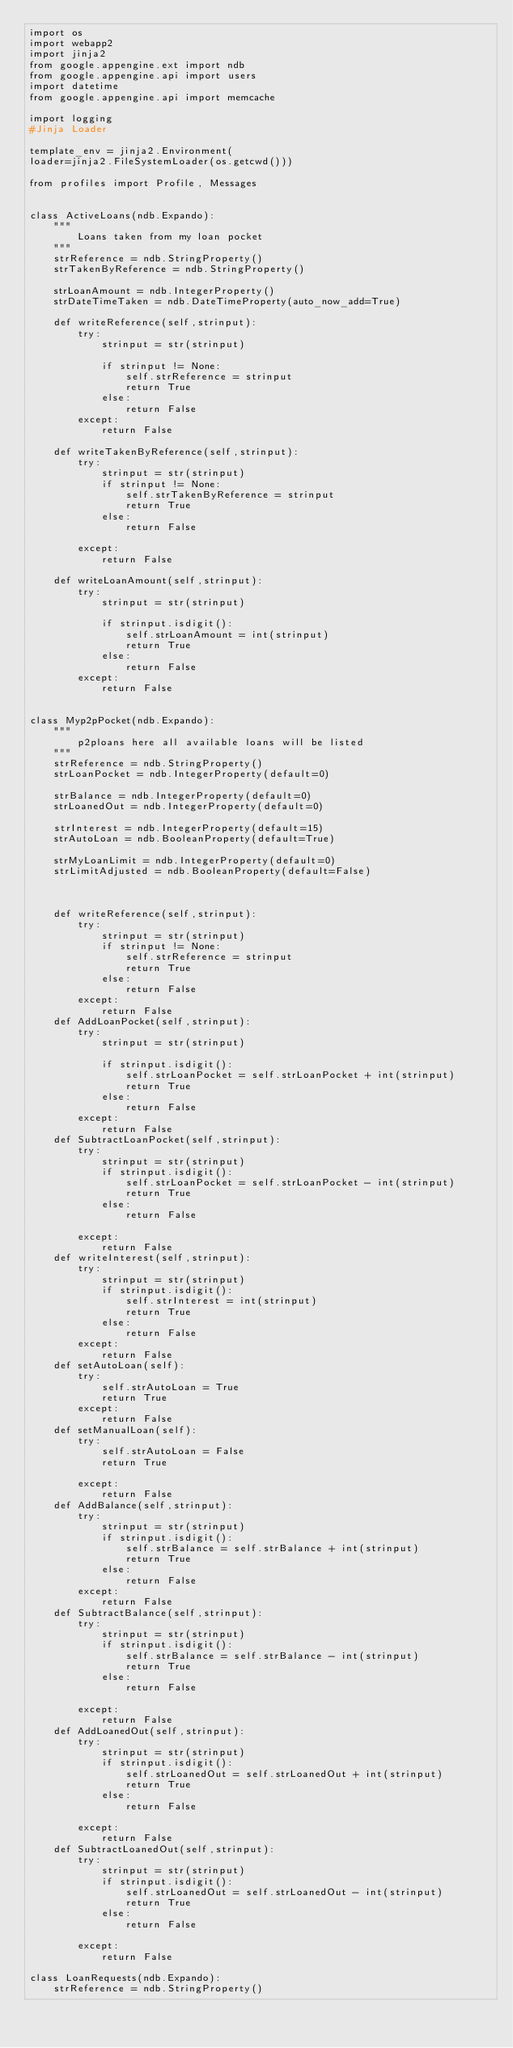Convert code to text. <code><loc_0><loc_0><loc_500><loc_500><_Python_>import os
import webapp2
import jinja2
from google.appengine.ext import ndb
from google.appengine.api import users
import datetime
from google.appengine.api import memcache

import logging
#Jinja Loader

template_env = jinja2.Environment(
loader=jinja2.FileSystemLoader(os.getcwd()))

from profiles import Profile, Messages


class ActiveLoans(ndb.Expando):
    """
        Loans taken from my loan pocket
    """
    strReference = ndb.StringProperty()
    strTakenByReference = ndb.StringProperty()

    strLoanAmount = ndb.IntegerProperty()
    strDateTimeTaken = ndb.DateTimeProperty(auto_now_add=True)

    def writeReference(self,strinput):
        try:
            strinput = str(strinput)

            if strinput != None:
                self.strReference = strinput
                return True
            else:
                return False
        except:
            return False

    def writeTakenByReference(self,strinput):
        try:
            strinput = str(strinput)
            if strinput != None:
                self.strTakenByReference = strinput
                return True
            else:
                return False

        except:
            return False

    def writeLoanAmount(self,strinput):
        try:
            strinput = str(strinput)

            if strinput.isdigit():
                self.strLoanAmount = int(strinput)
                return True
            else:
                return False
        except:
            return False


class Myp2pPocket(ndb.Expando):
    """
        p2ploans here all available loans will be listed
    """
    strReference = ndb.StringProperty()
    strLoanPocket = ndb.IntegerProperty(default=0)

    strBalance = ndb.IntegerProperty(default=0)
    strLoanedOut = ndb.IntegerProperty(default=0)

    strInterest = ndb.IntegerProperty(default=15)
    strAutoLoan = ndb.BooleanProperty(default=True)

    strMyLoanLimit = ndb.IntegerProperty(default=0)
    strLimitAdjusted = ndb.BooleanProperty(default=False)



    def writeReference(self,strinput):
        try:
            strinput = str(strinput)
            if strinput != None:
                self.strReference = strinput
                return True
            else:
                return False
        except:
            return False
    def AddLoanPocket(self,strinput):
        try:
            strinput = str(strinput)

            if strinput.isdigit():
                self.strLoanPocket = self.strLoanPocket + int(strinput)
                return True
            else:
                return False
        except:
            return False
    def SubtractLoanPocket(self,strinput):
        try:
            strinput = str(strinput)
            if strinput.isdigit():
                self.strLoanPocket = self.strLoanPocket - int(strinput)
                return True
            else:
                return False

        except:
            return False
    def writeInterest(self,strinput):
        try:
            strinput = str(strinput)
            if strinput.isdigit():
                self.strInterest = int(strinput)
                return True
            else:
                return False
        except:
            return False
    def setAutoLoan(self):
        try:
            self.strAutoLoan = True
            return True
        except:
            return False
    def setManualLoan(self):
        try:
            self.strAutoLoan = False
            return True

        except:
            return False
    def AddBalance(self,strinput):
        try:
            strinput = str(strinput)
            if strinput.isdigit():
                self.strBalance = self.strBalance + int(strinput)
                return True
            else:
                return False
        except:
            return False
    def SubtractBalance(self,strinput):
        try:
            strinput = str(strinput)
            if strinput.isdigit():
                self.strBalance = self.strBalance - int(strinput)
                return True
            else:
                return False

        except:
            return False
    def AddLoanedOut(self,strinput):
        try:
            strinput = str(strinput)
            if strinput.isdigit():
                self.strLoanedOut = self.strLoanedOut + int(strinput)
                return True
            else:
                return False

        except:
            return False
    def SubtractLoanedOut(self,strinput):
        try:
            strinput = str(strinput)
            if strinput.isdigit():
                self.strLoanedOut = self.strLoanedOut - int(strinput)
                return True
            else:
                return False

        except:
            return False

class LoanRequests(ndb.Expando):
    strReference = ndb.StringProperty()</code> 